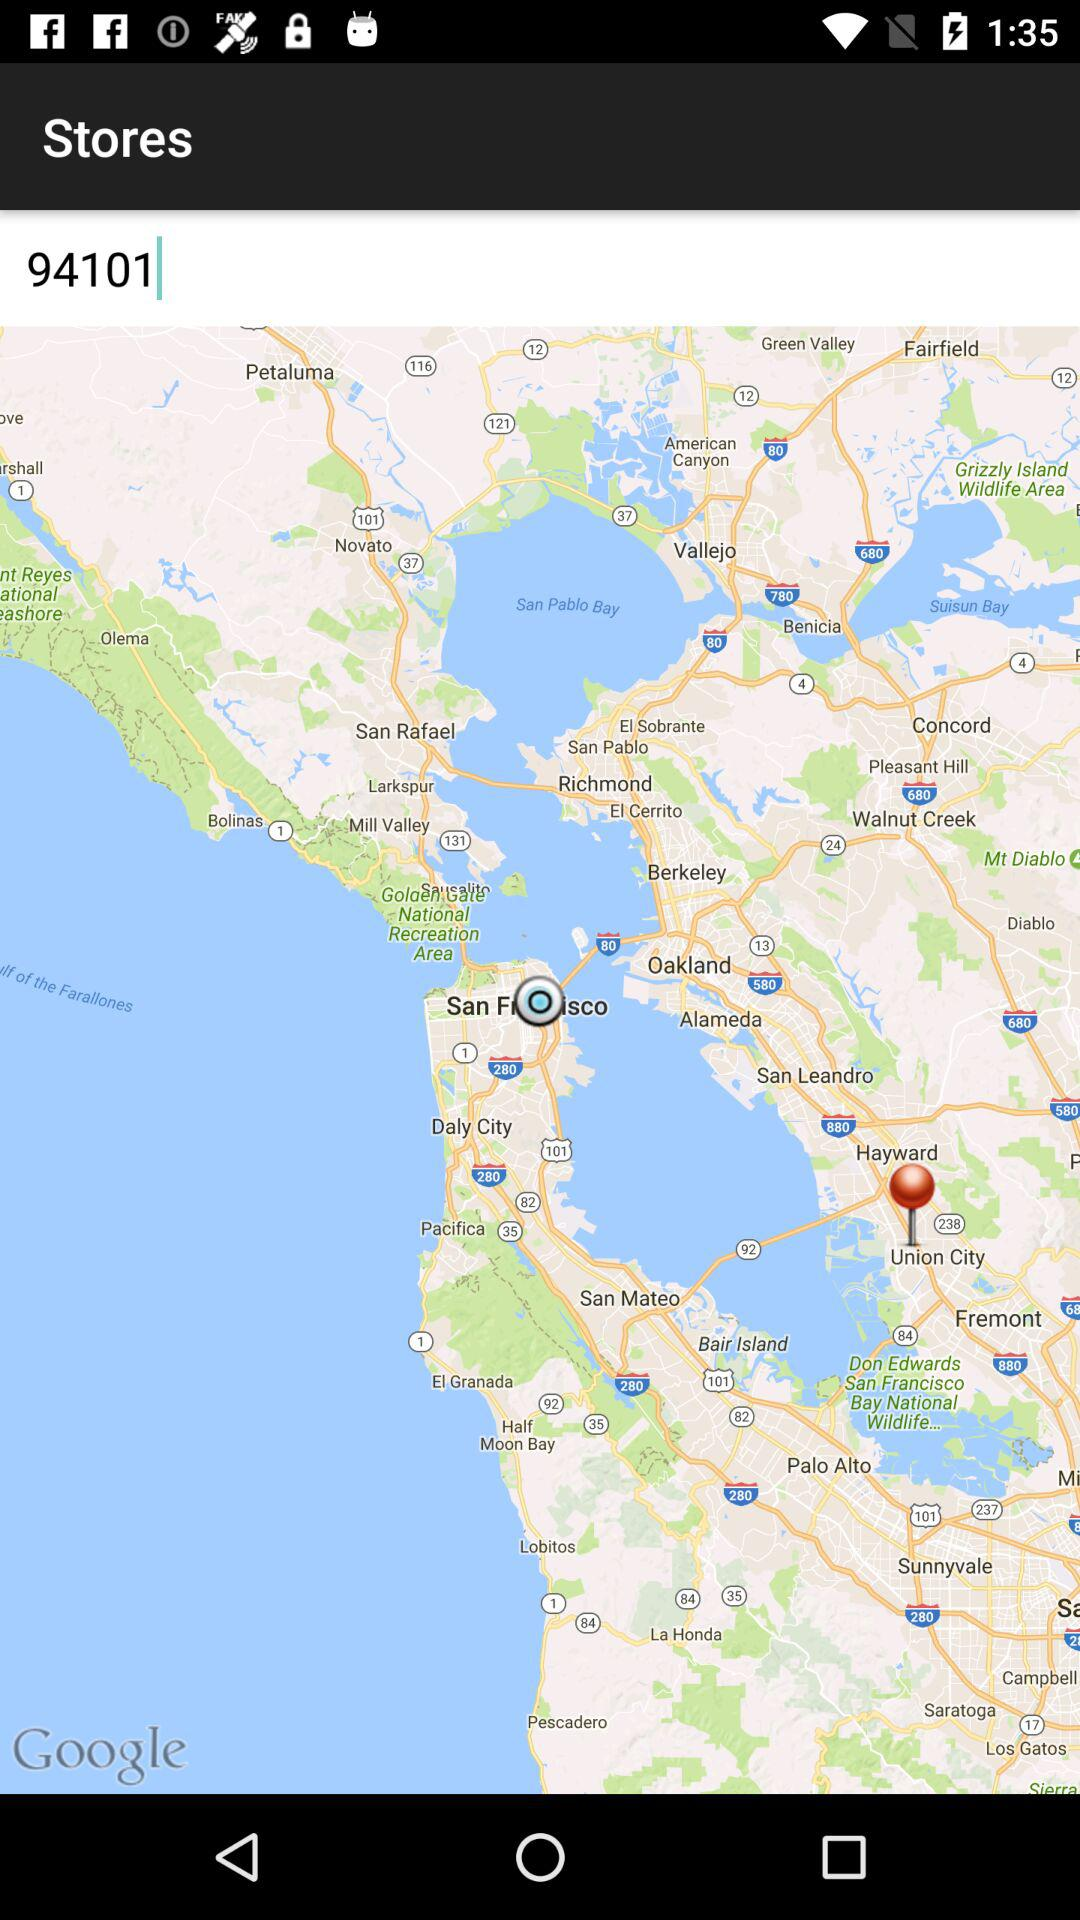What is the pincode? The pincode is 94101. 